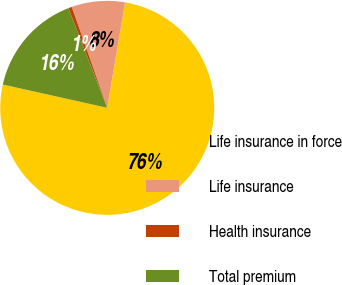Convert chart to OTSL. <chart><loc_0><loc_0><loc_500><loc_500><pie_chart><fcel>Life insurance in force<fcel>Life insurance<fcel>Health insurance<fcel>Total premium<nl><fcel>75.81%<fcel>8.06%<fcel>0.53%<fcel>15.59%<nl></chart> 